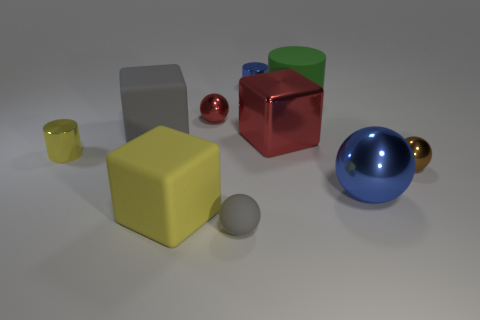There is a big cylinder that is to the right of the tiny shiny sphere on the left side of the big shiny thing that is to the right of the rubber cylinder; what color is it?
Your response must be concise. Green. What number of things are either big red matte objects or small yellow cylinders?
Provide a short and direct response. 1. What number of small gray things have the same shape as the tiny red metal object?
Give a very brief answer. 1. Does the gray cube have the same material as the tiny cylinder behind the green matte object?
Your answer should be very brief. No. The yellow cylinder that is made of the same material as the red block is what size?
Your answer should be compact. Small. There is a yellow thing that is in front of the large blue metallic sphere; how big is it?
Provide a short and direct response. Large. How many metallic cylinders have the same size as the brown ball?
Your response must be concise. 2. There is a thing that is the same color as the small rubber sphere; what is its size?
Make the answer very short. Large. Is there a big rubber cylinder of the same color as the matte sphere?
Offer a terse response. No. What color is the metallic cylinder that is the same size as the yellow shiny object?
Provide a succinct answer. Blue. 